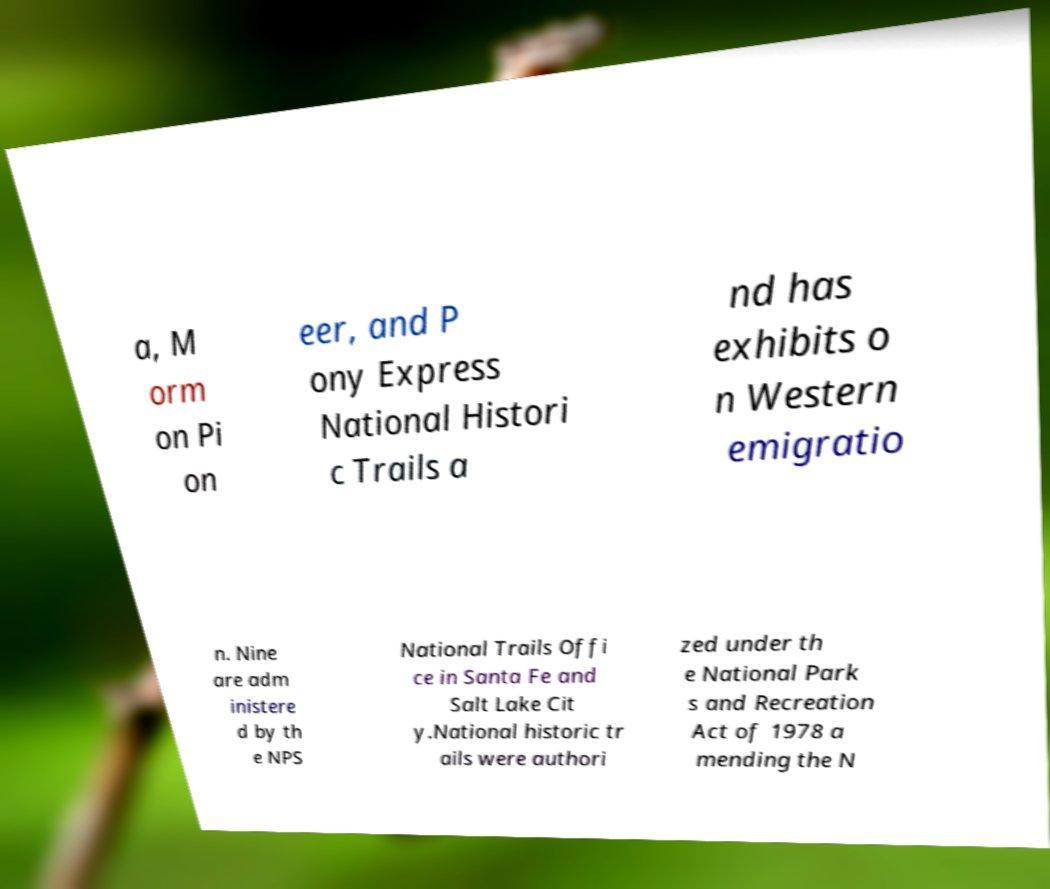I need the written content from this picture converted into text. Can you do that? a, M orm on Pi on eer, and P ony Express National Histori c Trails a nd has exhibits o n Western emigratio n. Nine are adm inistere d by th e NPS National Trails Offi ce in Santa Fe and Salt Lake Cit y.National historic tr ails were authori zed under th e National Park s and Recreation Act of 1978 a mending the N 